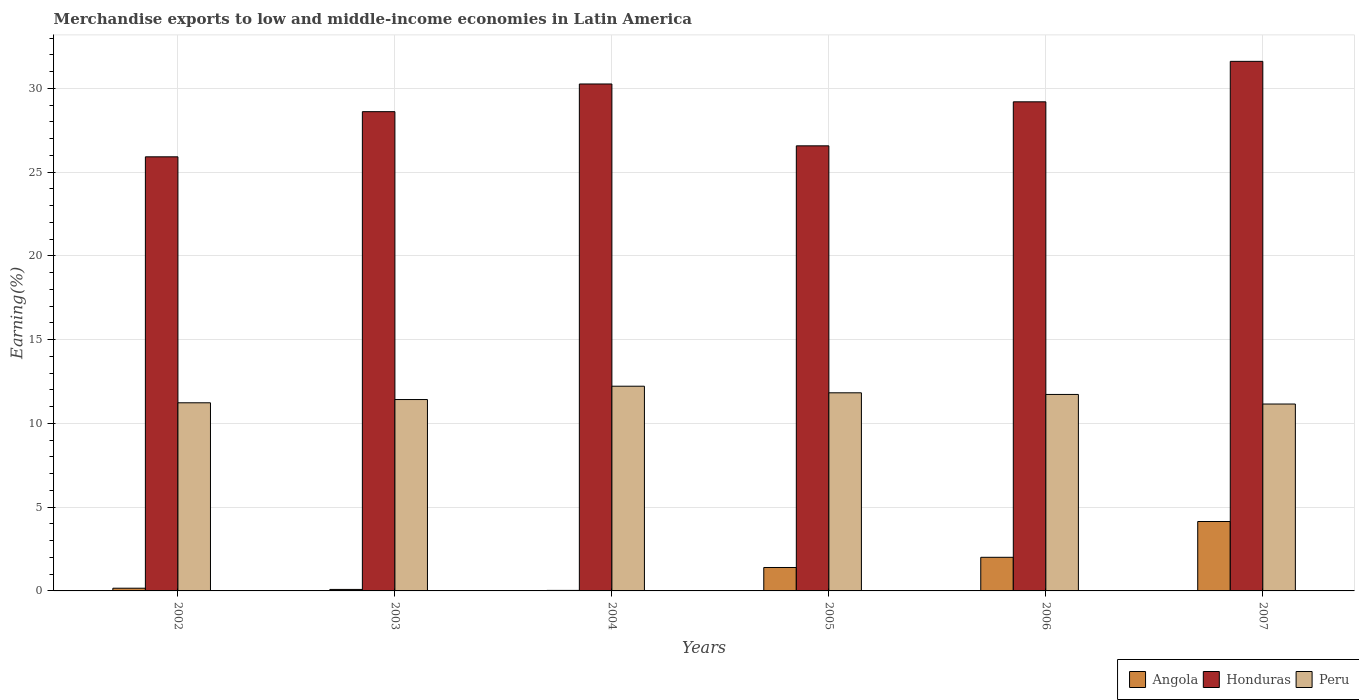How many groups of bars are there?
Your response must be concise. 6. What is the label of the 6th group of bars from the left?
Offer a very short reply. 2007. In how many cases, is the number of bars for a given year not equal to the number of legend labels?
Provide a short and direct response. 0. What is the percentage of amount earned from merchandise exports in Honduras in 2004?
Provide a short and direct response. 30.27. Across all years, what is the maximum percentage of amount earned from merchandise exports in Honduras?
Offer a terse response. 31.62. Across all years, what is the minimum percentage of amount earned from merchandise exports in Angola?
Make the answer very short. 0.03. In which year was the percentage of amount earned from merchandise exports in Angola maximum?
Your answer should be very brief. 2007. In which year was the percentage of amount earned from merchandise exports in Peru minimum?
Ensure brevity in your answer.  2007. What is the total percentage of amount earned from merchandise exports in Peru in the graph?
Offer a terse response. 69.6. What is the difference between the percentage of amount earned from merchandise exports in Peru in 2002 and that in 2004?
Your answer should be compact. -0.99. What is the difference between the percentage of amount earned from merchandise exports in Angola in 2006 and the percentage of amount earned from merchandise exports in Peru in 2002?
Offer a very short reply. -9.23. What is the average percentage of amount earned from merchandise exports in Honduras per year?
Offer a terse response. 28.7. In the year 2003, what is the difference between the percentage of amount earned from merchandise exports in Angola and percentage of amount earned from merchandise exports in Honduras?
Provide a succinct answer. -28.53. What is the ratio of the percentage of amount earned from merchandise exports in Honduras in 2004 to that in 2007?
Provide a short and direct response. 0.96. Is the difference between the percentage of amount earned from merchandise exports in Angola in 2005 and 2007 greater than the difference between the percentage of amount earned from merchandise exports in Honduras in 2005 and 2007?
Offer a terse response. Yes. What is the difference between the highest and the second highest percentage of amount earned from merchandise exports in Peru?
Ensure brevity in your answer.  0.39. What is the difference between the highest and the lowest percentage of amount earned from merchandise exports in Honduras?
Ensure brevity in your answer.  5.7. What does the 2nd bar from the left in 2005 represents?
Give a very brief answer. Honduras. What does the 3rd bar from the right in 2004 represents?
Ensure brevity in your answer.  Angola. How many bars are there?
Give a very brief answer. 18. Are all the bars in the graph horizontal?
Make the answer very short. No. How many years are there in the graph?
Give a very brief answer. 6. Where does the legend appear in the graph?
Keep it short and to the point. Bottom right. How are the legend labels stacked?
Provide a short and direct response. Horizontal. What is the title of the graph?
Your response must be concise. Merchandise exports to low and middle-income economies in Latin America. Does "OECD members" appear as one of the legend labels in the graph?
Provide a short and direct response. No. What is the label or title of the Y-axis?
Your response must be concise. Earning(%). What is the Earning(%) of Angola in 2002?
Ensure brevity in your answer.  0.16. What is the Earning(%) of Honduras in 2002?
Provide a succinct answer. 25.92. What is the Earning(%) of Peru in 2002?
Offer a terse response. 11.23. What is the Earning(%) in Angola in 2003?
Provide a succinct answer. 0.09. What is the Earning(%) of Honduras in 2003?
Your answer should be compact. 28.62. What is the Earning(%) in Peru in 2003?
Keep it short and to the point. 11.43. What is the Earning(%) in Angola in 2004?
Provide a succinct answer. 0.03. What is the Earning(%) in Honduras in 2004?
Provide a succinct answer. 30.27. What is the Earning(%) of Peru in 2004?
Ensure brevity in your answer.  12.22. What is the Earning(%) of Angola in 2005?
Your response must be concise. 1.4. What is the Earning(%) in Honduras in 2005?
Give a very brief answer. 26.57. What is the Earning(%) of Peru in 2005?
Your answer should be very brief. 11.83. What is the Earning(%) in Angola in 2006?
Your response must be concise. 2.01. What is the Earning(%) of Honduras in 2006?
Offer a terse response. 29.2. What is the Earning(%) of Peru in 2006?
Your answer should be compact. 11.73. What is the Earning(%) in Angola in 2007?
Your answer should be very brief. 4.14. What is the Earning(%) of Honduras in 2007?
Your response must be concise. 31.62. What is the Earning(%) of Peru in 2007?
Ensure brevity in your answer.  11.16. Across all years, what is the maximum Earning(%) in Angola?
Keep it short and to the point. 4.14. Across all years, what is the maximum Earning(%) of Honduras?
Provide a succinct answer. 31.62. Across all years, what is the maximum Earning(%) in Peru?
Keep it short and to the point. 12.22. Across all years, what is the minimum Earning(%) of Angola?
Offer a terse response. 0.03. Across all years, what is the minimum Earning(%) in Honduras?
Offer a terse response. 25.92. Across all years, what is the minimum Earning(%) of Peru?
Provide a short and direct response. 11.16. What is the total Earning(%) of Angola in the graph?
Offer a terse response. 7.83. What is the total Earning(%) in Honduras in the graph?
Offer a very short reply. 172.2. What is the total Earning(%) in Peru in the graph?
Give a very brief answer. 69.6. What is the difference between the Earning(%) in Angola in 2002 and that in 2003?
Give a very brief answer. 0.07. What is the difference between the Earning(%) in Honduras in 2002 and that in 2003?
Ensure brevity in your answer.  -2.7. What is the difference between the Earning(%) in Peru in 2002 and that in 2003?
Keep it short and to the point. -0.19. What is the difference between the Earning(%) of Angola in 2002 and that in 2004?
Offer a very short reply. 0.13. What is the difference between the Earning(%) in Honduras in 2002 and that in 2004?
Ensure brevity in your answer.  -4.35. What is the difference between the Earning(%) in Peru in 2002 and that in 2004?
Your answer should be very brief. -0.99. What is the difference between the Earning(%) in Angola in 2002 and that in 2005?
Your response must be concise. -1.24. What is the difference between the Earning(%) in Honduras in 2002 and that in 2005?
Ensure brevity in your answer.  -0.66. What is the difference between the Earning(%) in Peru in 2002 and that in 2005?
Provide a short and direct response. -0.6. What is the difference between the Earning(%) in Angola in 2002 and that in 2006?
Give a very brief answer. -1.85. What is the difference between the Earning(%) in Honduras in 2002 and that in 2006?
Offer a terse response. -3.28. What is the difference between the Earning(%) of Peru in 2002 and that in 2006?
Your answer should be very brief. -0.5. What is the difference between the Earning(%) of Angola in 2002 and that in 2007?
Your response must be concise. -3.98. What is the difference between the Earning(%) of Honduras in 2002 and that in 2007?
Your answer should be very brief. -5.7. What is the difference between the Earning(%) in Peru in 2002 and that in 2007?
Offer a very short reply. 0.07. What is the difference between the Earning(%) in Angola in 2003 and that in 2004?
Offer a terse response. 0.06. What is the difference between the Earning(%) of Honduras in 2003 and that in 2004?
Your answer should be compact. -1.65. What is the difference between the Earning(%) in Peru in 2003 and that in 2004?
Your answer should be very brief. -0.8. What is the difference between the Earning(%) in Angola in 2003 and that in 2005?
Give a very brief answer. -1.31. What is the difference between the Earning(%) of Honduras in 2003 and that in 2005?
Offer a very short reply. 2.04. What is the difference between the Earning(%) in Peru in 2003 and that in 2005?
Give a very brief answer. -0.4. What is the difference between the Earning(%) of Angola in 2003 and that in 2006?
Your answer should be compact. -1.92. What is the difference between the Earning(%) of Honduras in 2003 and that in 2006?
Make the answer very short. -0.59. What is the difference between the Earning(%) of Peru in 2003 and that in 2006?
Make the answer very short. -0.3. What is the difference between the Earning(%) in Angola in 2003 and that in 2007?
Offer a very short reply. -4.06. What is the difference between the Earning(%) in Honduras in 2003 and that in 2007?
Provide a short and direct response. -3. What is the difference between the Earning(%) of Peru in 2003 and that in 2007?
Keep it short and to the point. 0.27. What is the difference between the Earning(%) in Angola in 2004 and that in 2005?
Offer a terse response. -1.37. What is the difference between the Earning(%) in Honduras in 2004 and that in 2005?
Your answer should be very brief. 3.69. What is the difference between the Earning(%) of Peru in 2004 and that in 2005?
Offer a very short reply. 0.39. What is the difference between the Earning(%) in Angola in 2004 and that in 2006?
Your answer should be compact. -1.98. What is the difference between the Earning(%) in Honduras in 2004 and that in 2006?
Your answer should be very brief. 1.07. What is the difference between the Earning(%) in Peru in 2004 and that in 2006?
Your response must be concise. 0.49. What is the difference between the Earning(%) of Angola in 2004 and that in 2007?
Your answer should be very brief. -4.11. What is the difference between the Earning(%) in Honduras in 2004 and that in 2007?
Give a very brief answer. -1.35. What is the difference between the Earning(%) of Peru in 2004 and that in 2007?
Your answer should be very brief. 1.06. What is the difference between the Earning(%) in Angola in 2005 and that in 2006?
Ensure brevity in your answer.  -0.61. What is the difference between the Earning(%) of Honduras in 2005 and that in 2006?
Provide a short and direct response. -2.63. What is the difference between the Earning(%) of Peru in 2005 and that in 2006?
Give a very brief answer. 0.1. What is the difference between the Earning(%) in Angola in 2005 and that in 2007?
Your answer should be compact. -2.75. What is the difference between the Earning(%) of Honduras in 2005 and that in 2007?
Keep it short and to the point. -5.04. What is the difference between the Earning(%) in Peru in 2005 and that in 2007?
Offer a terse response. 0.67. What is the difference between the Earning(%) of Angola in 2006 and that in 2007?
Offer a very short reply. -2.14. What is the difference between the Earning(%) in Honduras in 2006 and that in 2007?
Make the answer very short. -2.42. What is the difference between the Earning(%) of Peru in 2006 and that in 2007?
Provide a short and direct response. 0.57. What is the difference between the Earning(%) in Angola in 2002 and the Earning(%) in Honduras in 2003?
Give a very brief answer. -28.45. What is the difference between the Earning(%) in Angola in 2002 and the Earning(%) in Peru in 2003?
Offer a very short reply. -11.27. What is the difference between the Earning(%) of Honduras in 2002 and the Earning(%) of Peru in 2003?
Keep it short and to the point. 14.49. What is the difference between the Earning(%) in Angola in 2002 and the Earning(%) in Honduras in 2004?
Offer a very short reply. -30.11. What is the difference between the Earning(%) in Angola in 2002 and the Earning(%) in Peru in 2004?
Your answer should be compact. -12.06. What is the difference between the Earning(%) in Honduras in 2002 and the Earning(%) in Peru in 2004?
Your answer should be compact. 13.7. What is the difference between the Earning(%) in Angola in 2002 and the Earning(%) in Honduras in 2005?
Offer a very short reply. -26.41. What is the difference between the Earning(%) in Angola in 2002 and the Earning(%) in Peru in 2005?
Make the answer very short. -11.67. What is the difference between the Earning(%) of Honduras in 2002 and the Earning(%) of Peru in 2005?
Offer a terse response. 14.09. What is the difference between the Earning(%) of Angola in 2002 and the Earning(%) of Honduras in 2006?
Give a very brief answer. -29.04. What is the difference between the Earning(%) of Angola in 2002 and the Earning(%) of Peru in 2006?
Provide a succinct answer. -11.57. What is the difference between the Earning(%) of Honduras in 2002 and the Earning(%) of Peru in 2006?
Provide a succinct answer. 14.19. What is the difference between the Earning(%) of Angola in 2002 and the Earning(%) of Honduras in 2007?
Give a very brief answer. -31.46. What is the difference between the Earning(%) of Angola in 2002 and the Earning(%) of Peru in 2007?
Give a very brief answer. -11. What is the difference between the Earning(%) in Honduras in 2002 and the Earning(%) in Peru in 2007?
Your answer should be compact. 14.76. What is the difference between the Earning(%) of Angola in 2003 and the Earning(%) of Honduras in 2004?
Your answer should be compact. -30.18. What is the difference between the Earning(%) of Angola in 2003 and the Earning(%) of Peru in 2004?
Your answer should be very brief. -12.13. What is the difference between the Earning(%) in Honduras in 2003 and the Earning(%) in Peru in 2004?
Your answer should be very brief. 16.39. What is the difference between the Earning(%) in Angola in 2003 and the Earning(%) in Honduras in 2005?
Offer a very short reply. -26.49. What is the difference between the Earning(%) of Angola in 2003 and the Earning(%) of Peru in 2005?
Make the answer very short. -11.74. What is the difference between the Earning(%) of Honduras in 2003 and the Earning(%) of Peru in 2005?
Keep it short and to the point. 16.79. What is the difference between the Earning(%) in Angola in 2003 and the Earning(%) in Honduras in 2006?
Make the answer very short. -29.11. What is the difference between the Earning(%) in Angola in 2003 and the Earning(%) in Peru in 2006?
Provide a succinct answer. -11.64. What is the difference between the Earning(%) in Honduras in 2003 and the Earning(%) in Peru in 2006?
Your answer should be very brief. 16.88. What is the difference between the Earning(%) of Angola in 2003 and the Earning(%) of Honduras in 2007?
Your answer should be compact. -31.53. What is the difference between the Earning(%) in Angola in 2003 and the Earning(%) in Peru in 2007?
Provide a short and direct response. -11.07. What is the difference between the Earning(%) of Honduras in 2003 and the Earning(%) of Peru in 2007?
Your response must be concise. 17.46. What is the difference between the Earning(%) in Angola in 2004 and the Earning(%) in Honduras in 2005?
Your answer should be very brief. -26.54. What is the difference between the Earning(%) in Angola in 2004 and the Earning(%) in Peru in 2005?
Your answer should be compact. -11.8. What is the difference between the Earning(%) of Honduras in 2004 and the Earning(%) of Peru in 2005?
Your answer should be very brief. 18.44. What is the difference between the Earning(%) of Angola in 2004 and the Earning(%) of Honduras in 2006?
Offer a very short reply. -29.17. What is the difference between the Earning(%) of Angola in 2004 and the Earning(%) of Peru in 2006?
Your answer should be compact. -11.7. What is the difference between the Earning(%) in Honduras in 2004 and the Earning(%) in Peru in 2006?
Provide a succinct answer. 18.54. What is the difference between the Earning(%) in Angola in 2004 and the Earning(%) in Honduras in 2007?
Make the answer very short. -31.59. What is the difference between the Earning(%) in Angola in 2004 and the Earning(%) in Peru in 2007?
Your response must be concise. -11.13. What is the difference between the Earning(%) in Honduras in 2004 and the Earning(%) in Peru in 2007?
Your answer should be compact. 19.11. What is the difference between the Earning(%) in Angola in 2005 and the Earning(%) in Honduras in 2006?
Offer a very short reply. -27.8. What is the difference between the Earning(%) in Angola in 2005 and the Earning(%) in Peru in 2006?
Give a very brief answer. -10.33. What is the difference between the Earning(%) of Honduras in 2005 and the Earning(%) of Peru in 2006?
Offer a very short reply. 14.84. What is the difference between the Earning(%) of Angola in 2005 and the Earning(%) of Honduras in 2007?
Offer a very short reply. -30.22. What is the difference between the Earning(%) of Angola in 2005 and the Earning(%) of Peru in 2007?
Ensure brevity in your answer.  -9.76. What is the difference between the Earning(%) of Honduras in 2005 and the Earning(%) of Peru in 2007?
Offer a terse response. 15.42. What is the difference between the Earning(%) of Angola in 2006 and the Earning(%) of Honduras in 2007?
Offer a terse response. -29.61. What is the difference between the Earning(%) in Angola in 2006 and the Earning(%) in Peru in 2007?
Provide a short and direct response. -9.15. What is the difference between the Earning(%) of Honduras in 2006 and the Earning(%) of Peru in 2007?
Keep it short and to the point. 18.04. What is the average Earning(%) of Angola per year?
Your answer should be compact. 1.31. What is the average Earning(%) of Honduras per year?
Your answer should be compact. 28.7. What is the average Earning(%) in Peru per year?
Provide a short and direct response. 11.6. In the year 2002, what is the difference between the Earning(%) in Angola and Earning(%) in Honduras?
Give a very brief answer. -25.76. In the year 2002, what is the difference between the Earning(%) in Angola and Earning(%) in Peru?
Provide a short and direct response. -11.07. In the year 2002, what is the difference between the Earning(%) of Honduras and Earning(%) of Peru?
Your answer should be compact. 14.69. In the year 2003, what is the difference between the Earning(%) of Angola and Earning(%) of Honduras?
Your answer should be compact. -28.53. In the year 2003, what is the difference between the Earning(%) of Angola and Earning(%) of Peru?
Provide a succinct answer. -11.34. In the year 2003, what is the difference between the Earning(%) in Honduras and Earning(%) in Peru?
Provide a succinct answer. 17.19. In the year 2004, what is the difference between the Earning(%) in Angola and Earning(%) in Honduras?
Provide a short and direct response. -30.24. In the year 2004, what is the difference between the Earning(%) of Angola and Earning(%) of Peru?
Offer a very short reply. -12.19. In the year 2004, what is the difference between the Earning(%) of Honduras and Earning(%) of Peru?
Provide a short and direct response. 18.05. In the year 2005, what is the difference between the Earning(%) of Angola and Earning(%) of Honduras?
Your response must be concise. -25.18. In the year 2005, what is the difference between the Earning(%) in Angola and Earning(%) in Peru?
Offer a very short reply. -10.43. In the year 2005, what is the difference between the Earning(%) in Honduras and Earning(%) in Peru?
Your answer should be compact. 14.75. In the year 2006, what is the difference between the Earning(%) of Angola and Earning(%) of Honduras?
Your answer should be compact. -27.2. In the year 2006, what is the difference between the Earning(%) in Angola and Earning(%) in Peru?
Your response must be concise. -9.72. In the year 2006, what is the difference between the Earning(%) of Honduras and Earning(%) of Peru?
Provide a succinct answer. 17.47. In the year 2007, what is the difference between the Earning(%) of Angola and Earning(%) of Honduras?
Keep it short and to the point. -27.48. In the year 2007, what is the difference between the Earning(%) in Angola and Earning(%) in Peru?
Provide a short and direct response. -7.01. In the year 2007, what is the difference between the Earning(%) in Honduras and Earning(%) in Peru?
Keep it short and to the point. 20.46. What is the ratio of the Earning(%) in Angola in 2002 to that in 2003?
Your response must be concise. 1.82. What is the ratio of the Earning(%) of Honduras in 2002 to that in 2003?
Your answer should be compact. 0.91. What is the ratio of the Earning(%) in Angola in 2002 to that in 2004?
Provide a short and direct response. 5.13. What is the ratio of the Earning(%) in Honduras in 2002 to that in 2004?
Offer a terse response. 0.86. What is the ratio of the Earning(%) in Peru in 2002 to that in 2004?
Ensure brevity in your answer.  0.92. What is the ratio of the Earning(%) in Angola in 2002 to that in 2005?
Your answer should be compact. 0.12. What is the ratio of the Earning(%) in Honduras in 2002 to that in 2005?
Provide a short and direct response. 0.98. What is the ratio of the Earning(%) of Peru in 2002 to that in 2005?
Offer a very short reply. 0.95. What is the ratio of the Earning(%) in Angola in 2002 to that in 2006?
Provide a short and direct response. 0.08. What is the ratio of the Earning(%) in Honduras in 2002 to that in 2006?
Provide a succinct answer. 0.89. What is the ratio of the Earning(%) of Peru in 2002 to that in 2006?
Your answer should be compact. 0.96. What is the ratio of the Earning(%) of Angola in 2002 to that in 2007?
Offer a very short reply. 0.04. What is the ratio of the Earning(%) in Honduras in 2002 to that in 2007?
Keep it short and to the point. 0.82. What is the ratio of the Earning(%) in Peru in 2002 to that in 2007?
Ensure brevity in your answer.  1.01. What is the ratio of the Earning(%) of Angola in 2003 to that in 2004?
Your answer should be very brief. 2.81. What is the ratio of the Earning(%) in Honduras in 2003 to that in 2004?
Your response must be concise. 0.95. What is the ratio of the Earning(%) of Peru in 2003 to that in 2004?
Make the answer very short. 0.93. What is the ratio of the Earning(%) of Angola in 2003 to that in 2005?
Provide a succinct answer. 0.06. What is the ratio of the Earning(%) of Honduras in 2003 to that in 2005?
Provide a short and direct response. 1.08. What is the ratio of the Earning(%) in Angola in 2003 to that in 2006?
Make the answer very short. 0.04. What is the ratio of the Earning(%) of Honduras in 2003 to that in 2006?
Provide a succinct answer. 0.98. What is the ratio of the Earning(%) of Peru in 2003 to that in 2006?
Keep it short and to the point. 0.97. What is the ratio of the Earning(%) in Angola in 2003 to that in 2007?
Your answer should be very brief. 0.02. What is the ratio of the Earning(%) of Honduras in 2003 to that in 2007?
Make the answer very short. 0.91. What is the ratio of the Earning(%) of Angola in 2004 to that in 2005?
Provide a short and direct response. 0.02. What is the ratio of the Earning(%) of Honduras in 2004 to that in 2005?
Give a very brief answer. 1.14. What is the ratio of the Earning(%) of Peru in 2004 to that in 2005?
Ensure brevity in your answer.  1.03. What is the ratio of the Earning(%) of Angola in 2004 to that in 2006?
Your answer should be compact. 0.02. What is the ratio of the Earning(%) in Honduras in 2004 to that in 2006?
Provide a short and direct response. 1.04. What is the ratio of the Earning(%) of Peru in 2004 to that in 2006?
Make the answer very short. 1.04. What is the ratio of the Earning(%) in Angola in 2004 to that in 2007?
Provide a succinct answer. 0.01. What is the ratio of the Earning(%) in Honduras in 2004 to that in 2007?
Offer a terse response. 0.96. What is the ratio of the Earning(%) of Peru in 2004 to that in 2007?
Offer a terse response. 1.1. What is the ratio of the Earning(%) of Angola in 2005 to that in 2006?
Make the answer very short. 0.7. What is the ratio of the Earning(%) in Honduras in 2005 to that in 2006?
Provide a succinct answer. 0.91. What is the ratio of the Earning(%) of Peru in 2005 to that in 2006?
Make the answer very short. 1.01. What is the ratio of the Earning(%) of Angola in 2005 to that in 2007?
Your answer should be very brief. 0.34. What is the ratio of the Earning(%) of Honduras in 2005 to that in 2007?
Your answer should be very brief. 0.84. What is the ratio of the Earning(%) of Peru in 2005 to that in 2007?
Your response must be concise. 1.06. What is the ratio of the Earning(%) of Angola in 2006 to that in 2007?
Offer a terse response. 0.48. What is the ratio of the Earning(%) in Honduras in 2006 to that in 2007?
Your answer should be very brief. 0.92. What is the ratio of the Earning(%) in Peru in 2006 to that in 2007?
Offer a terse response. 1.05. What is the difference between the highest and the second highest Earning(%) of Angola?
Provide a succinct answer. 2.14. What is the difference between the highest and the second highest Earning(%) in Honduras?
Your answer should be very brief. 1.35. What is the difference between the highest and the second highest Earning(%) of Peru?
Keep it short and to the point. 0.39. What is the difference between the highest and the lowest Earning(%) in Angola?
Keep it short and to the point. 4.11. What is the difference between the highest and the lowest Earning(%) in Honduras?
Ensure brevity in your answer.  5.7. What is the difference between the highest and the lowest Earning(%) of Peru?
Give a very brief answer. 1.06. 